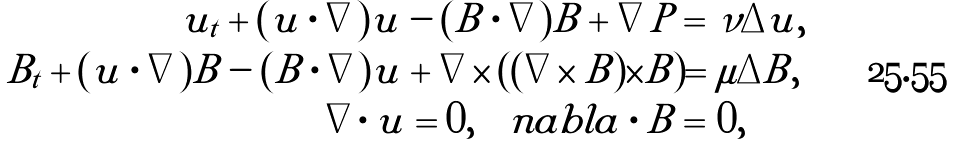<formula> <loc_0><loc_0><loc_500><loc_500>u _ { t } + ( u \cdot \nabla ) u - ( B \cdot \nabla ) B + \nabla P = & \ \nu \Delta u , \\ B _ { t } + ( u \cdot \nabla ) B - ( B \cdot \nabla ) u + \nabla \times ( ( \nabla \times B ) \times B ) = & \ \mu \Delta B , \\ \nabla \cdot u = 0 , \quad n a b l a \cdot B = & \ 0 ,</formula> 